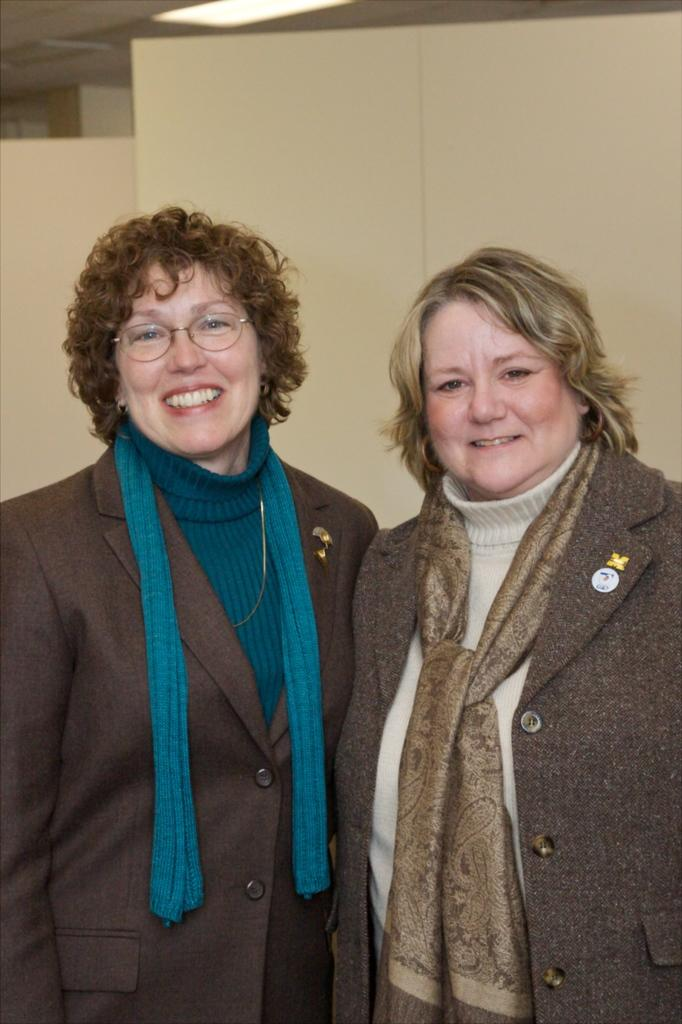How many women are in the image? There are two women in the image. What are the women doing in the image? The women are standing and smiling. Can you describe the lighting in the image? There is light visible in the image. What else can be seen in the image besides the women? Other objects are present in the background of the image. What type of berry can be heard making a sound in the image? There is no berry present in the image, and berries do not make sounds. Can you tell me how many monkeys are visible in the image? There are no monkeys present in the image. 